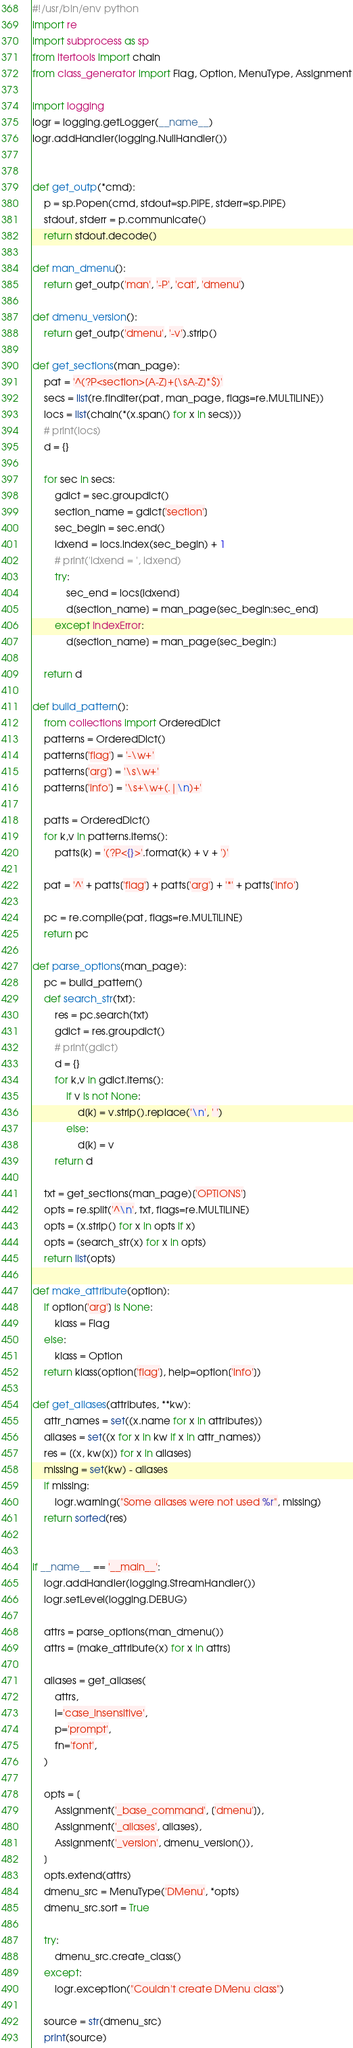Convert code to text. <code><loc_0><loc_0><loc_500><loc_500><_Python_>#!/usr/bin/env python
import re
import subprocess as sp
from itertools import chain
from class_generator import Flag, Option, MenuType, Assignment

import logging
logr = logging.getLogger(__name__)
logr.addHandler(logging.NullHandler())


def get_outp(*cmd):
    p = sp.Popen(cmd, stdout=sp.PIPE, stderr=sp.PIPE)
    stdout, stderr = p.communicate()
    return stdout.decode()

def man_dmenu():
    return get_outp('man', '-P', 'cat', 'dmenu')

def dmenu_version():
    return get_outp('dmenu', '-v').strip()

def get_sections(man_page):
    pat = '^(?P<section>[A-Z]+[\sA-Z]*$)'
    secs = list(re.finditer(pat, man_page, flags=re.MULTILINE))
    locs = list(chain(*(x.span() for x in secs)))
    # print(locs)
    d = {}
    
    for sec in secs:
        gdict = sec.groupdict()
        section_name = gdict['section']
        sec_begin = sec.end()
        idxend = locs.index(sec_begin) + 1
        # print('idxend = ', idxend)
        try:
            sec_end = locs[idxend]
            d[section_name] = man_page[sec_begin:sec_end]
        except IndexError:
            d[section_name] = man_page[sec_begin:]

    return d

def build_pattern():
    from collections import OrderedDict
    patterns = OrderedDict()
    patterns['flag'] = '-\w+'
    patterns['arg'] = '\s\w+'
    patterns['info'] = '\s+\w+(.|\n)+'

    patts = OrderedDict()
    for k,v in patterns.items():
        patts[k] = '(?P<{}>'.format(k) + v + ')'

    pat = '^' + patts['flag'] + patts['arg'] + '*' + patts['info']

    pc = re.compile(pat, flags=re.MULTILINE)
    return pc

def parse_options(man_page):
    pc = build_pattern()
    def search_str(txt):
        res = pc.search(txt)
        gdict = res.groupdict()
        # print(gdict)
        d = {}
        for k,v in gdict.items():
            if v is not None:
                d[k] = v.strip().replace('\n', ' ')
            else:
                d[k] = v
        return d

    txt = get_sections(man_page)['OPTIONS']
    opts = re.split('^\n', txt, flags=re.MULTILINE)
    opts = (x.strip() for x in opts if x)
    opts = (search_str(x) for x in opts)
    return list(opts)

def make_attribute(option):
    if option['arg'] is None:
        klass = Flag
    else:
        klass = Option
    return klass(option['flag'], help=option['info'])

def get_aliases(attributes, **kw):
    attr_names = set((x.name for x in attributes))
    aliases = set((x for x in kw if x in attr_names))
    res = [(x, kw[x]) for x in aliases]
    missing = set(kw) - aliases
    if missing:
        logr.warning("Some aliases were not used %r", missing)
    return sorted(res)


if __name__ == '__main__':
    logr.addHandler(logging.StreamHandler())
    logr.setLevel(logging.DEBUG)

    attrs = parse_options(man_dmenu())
    attrs = [make_attribute(x) for x in attrs]

    aliases = get_aliases(
        attrs,
        i='case_insensitive',
        p='prompt',
        fn='font',
    )

    opts = [
        Assignment('_base_command', ['dmenu']),
        Assignment('_aliases', aliases),
        Assignment('_version', dmenu_version()),
    ]
    opts.extend(attrs)
    dmenu_src = MenuType('DMenu', *opts)
    dmenu_src.sort = True

    try:
        dmenu_src.create_class()
    except:
        logr.exception("Couldn't create DMenu class")

    source = str(dmenu_src)
    print(source)

</code> 